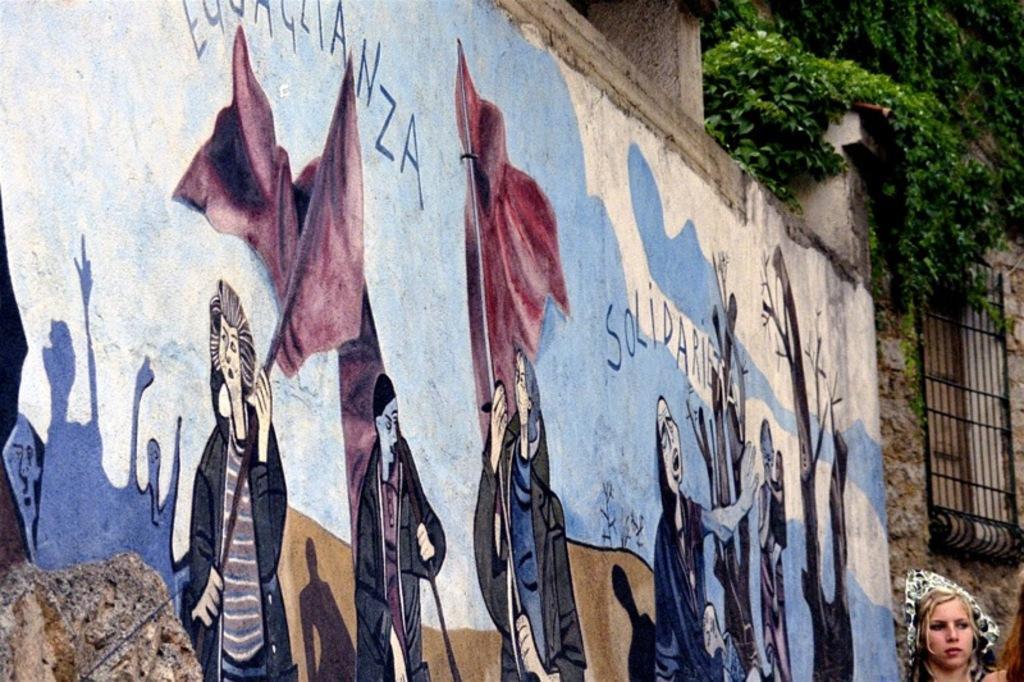Please provide a concise description of this image. In the image we can see there is a woman standing and there is a wall which painted. There are people standing and they are holding flags in their hand. There are plants grown on the building. 